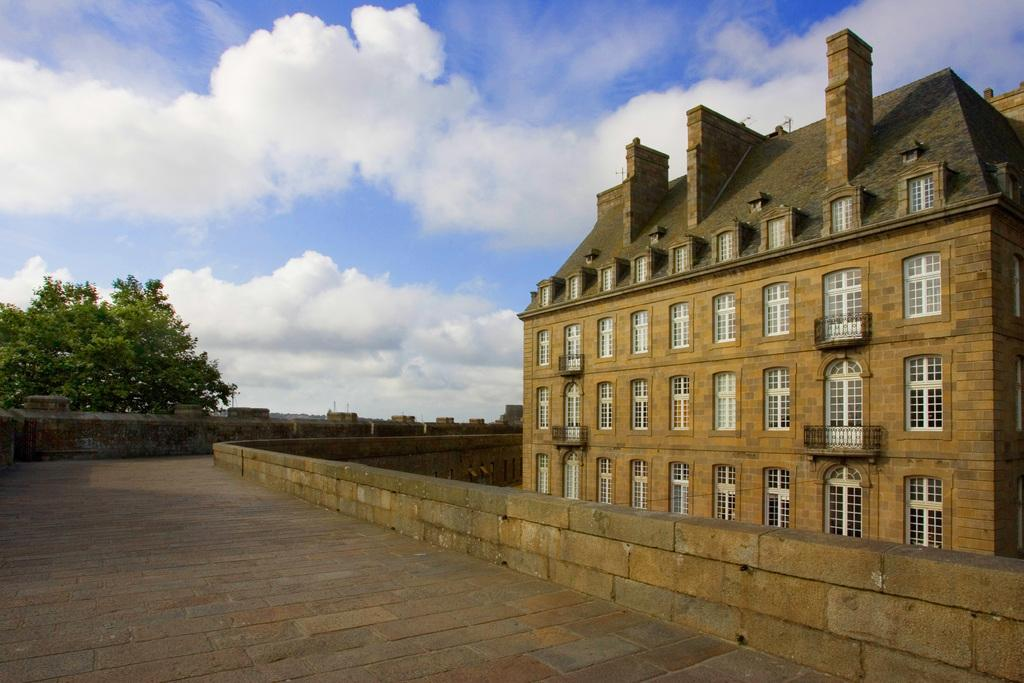What type of structure is present in the image? There is a building in the image. What features can be observed on the building? The building has windows and railing. What is visible beneath the building? There is ground visible in the image. What other structures are present in the image? There is a wall in the image. What type of vegetation is present in the image? There is a tree in the image. How would you describe the weather in the image? The sky is cloudy in the image. Can you see any airplanes taking off or landing at the airport in the image? There is no airport present in the image, so it is not possible to see any airplanes taking off or landing. What type of beetle can be seen crawling on the tree in the image? There is no beetle present in the image; only the tree is visible. 